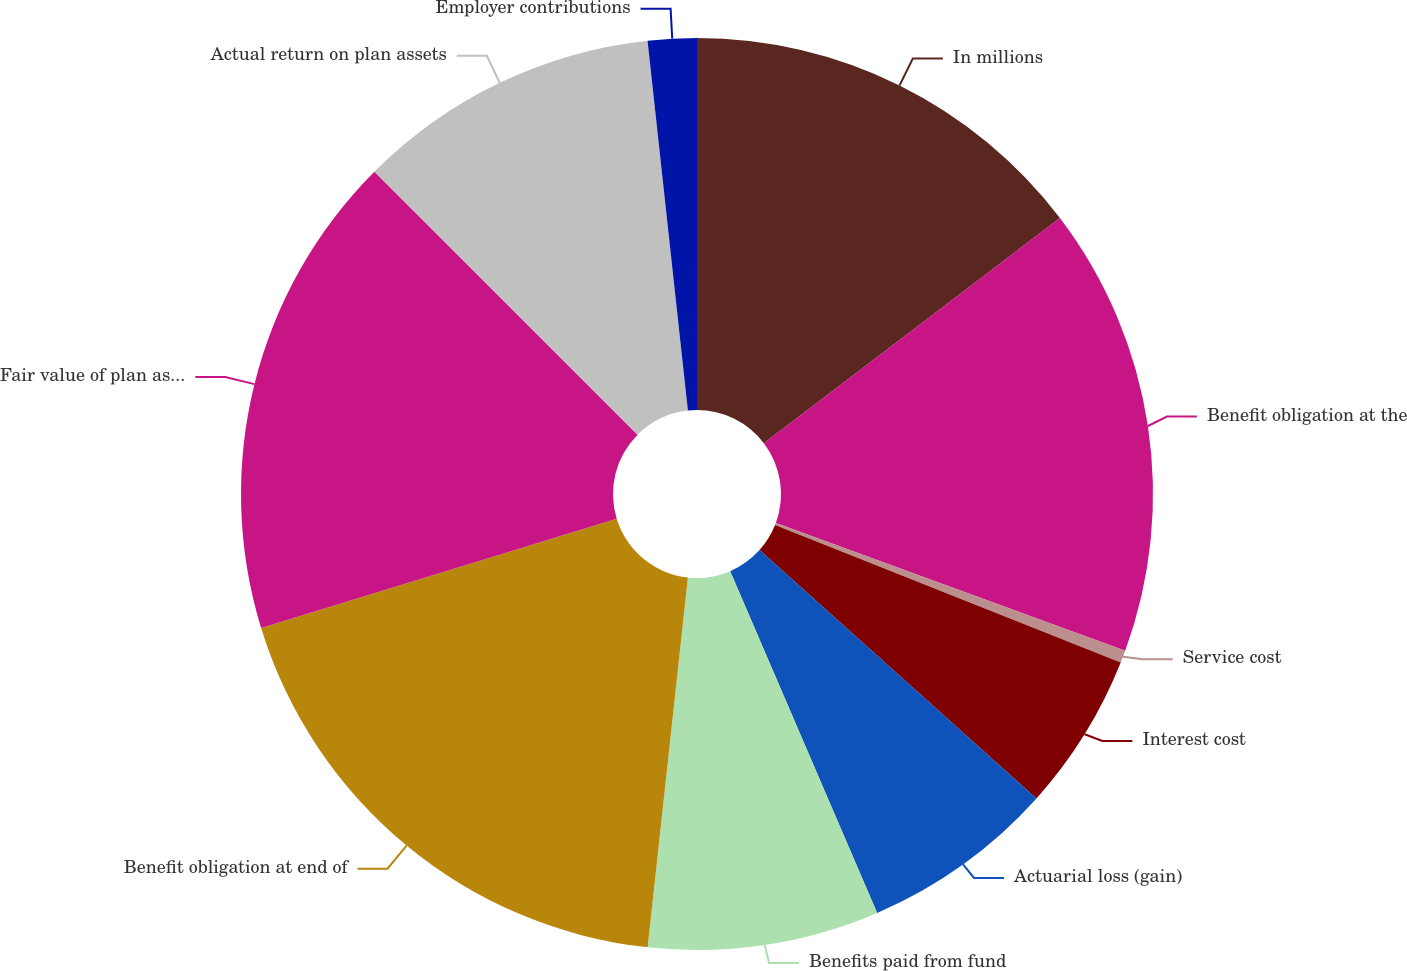<chart> <loc_0><loc_0><loc_500><loc_500><pie_chart><fcel>In millions<fcel>Benefit obligation at the<fcel>Service cost<fcel>Interest cost<fcel>Actuarial loss (gain)<fcel>Benefits paid from fund<fcel>Benefit obligation at end of<fcel>Fair value of plan assets at<fcel>Actual return on plan assets<fcel>Employer contributions<nl><fcel>14.65%<fcel>15.94%<fcel>0.44%<fcel>5.61%<fcel>6.9%<fcel>8.19%<fcel>18.53%<fcel>17.24%<fcel>10.78%<fcel>1.73%<nl></chart> 